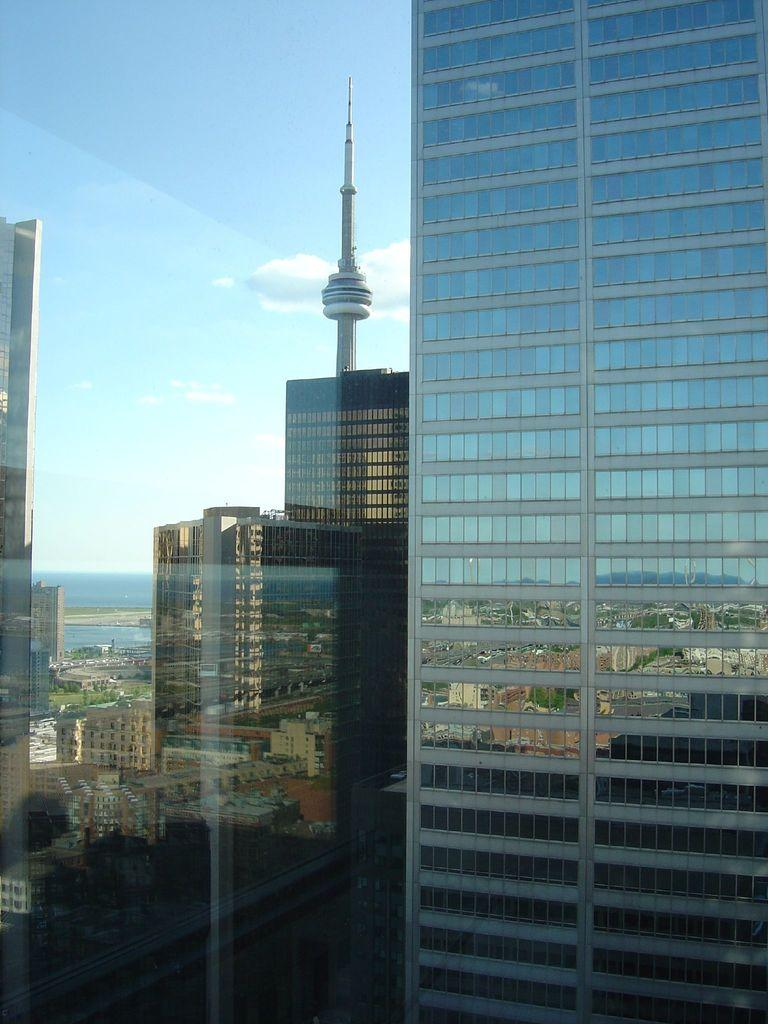What structures are visible in the image? There are buildings in the image. What can be seen in the sky in the background of the image? There are clouds in the sky in the background of the image. What type of jewel is hanging from the scarf in the image? There is no scarf or jewel present in the image; it only features buildings and clouds in the sky. 